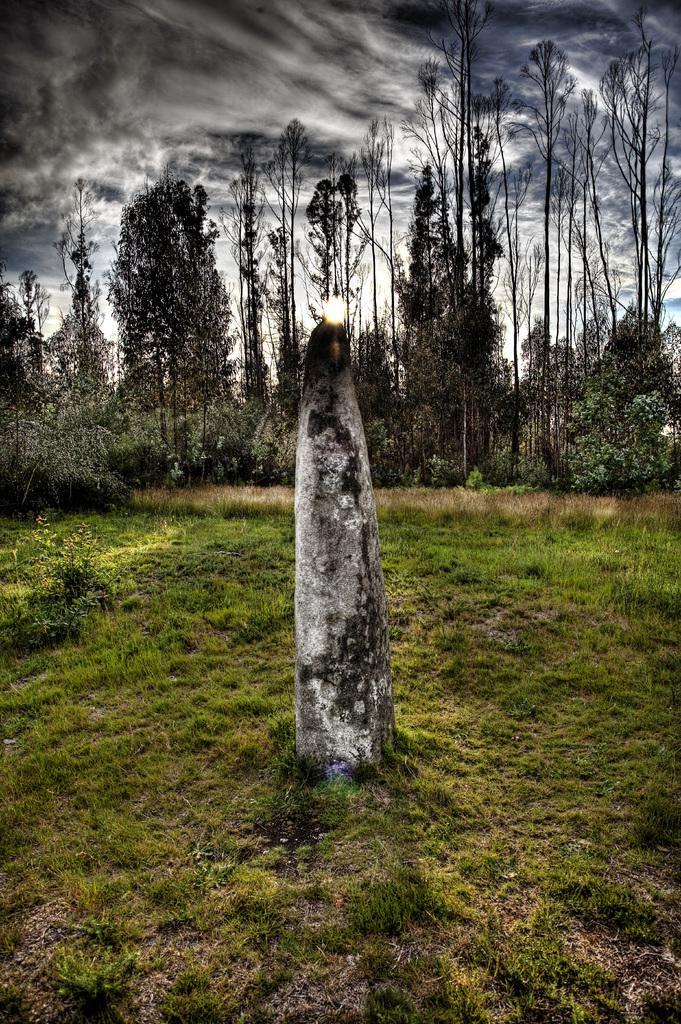Please provide a concise description of this image. In the center of the image, we can see a stone on the ground and in the background, there are trees and there is sun. At the top, there are clouds in the sky. 